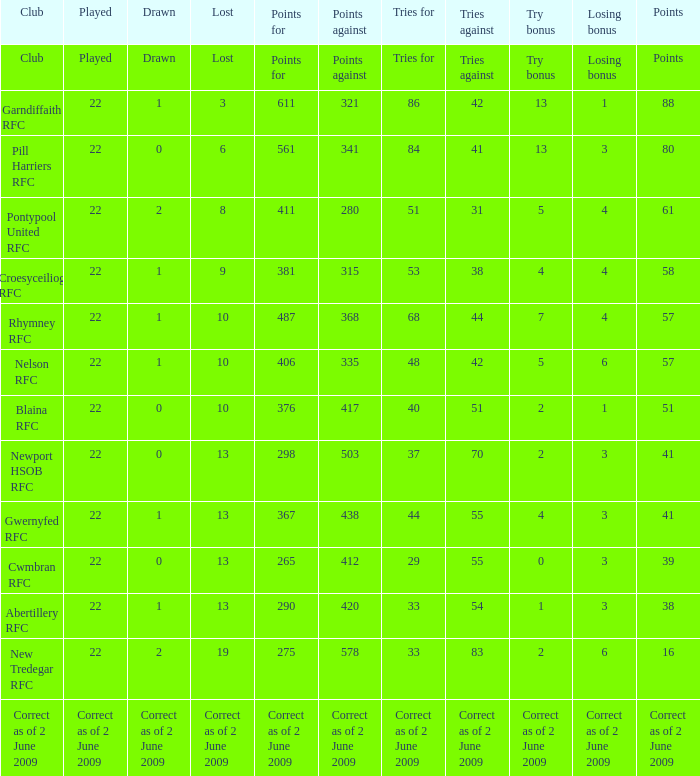Which club has 40 tries for? Blaina RFC. Could you parse the entire table as a dict? {'header': ['Club', 'Played', 'Drawn', 'Lost', 'Points for', 'Points against', 'Tries for', 'Tries against', 'Try bonus', 'Losing bonus', 'Points'], 'rows': [['Club', 'Played', 'Drawn', 'Lost', 'Points for', 'Points against', 'Tries for', 'Tries against', 'Try bonus', 'Losing bonus', 'Points'], ['Garndiffaith RFC', '22', '1', '3', '611', '321', '86', '42', '13', '1', '88'], ['Pill Harriers RFC', '22', '0', '6', '561', '341', '84', '41', '13', '3', '80'], ['Pontypool United RFC', '22', '2', '8', '411', '280', '51', '31', '5', '4', '61'], ['Croesyceiliog RFC', '22', '1', '9', '381', '315', '53', '38', '4', '4', '58'], ['Rhymney RFC', '22', '1', '10', '487', '368', '68', '44', '7', '4', '57'], ['Nelson RFC', '22', '1', '10', '406', '335', '48', '42', '5', '6', '57'], ['Blaina RFC', '22', '0', '10', '376', '417', '40', '51', '2', '1', '51'], ['Newport HSOB RFC', '22', '0', '13', '298', '503', '37', '70', '2', '3', '41'], ['Gwernyfed RFC', '22', '1', '13', '367', '438', '44', '55', '4', '3', '41'], ['Cwmbran RFC', '22', '0', '13', '265', '412', '29', '55', '0', '3', '39'], ['Abertillery RFC', '22', '1', '13', '290', '420', '33', '54', '1', '3', '38'], ['New Tredegar RFC', '22', '2', '19', '275', '578', '33', '83', '2', '6', '16'], ['Correct as of 2 June 2009', 'Correct as of 2 June 2009', 'Correct as of 2 June 2009', 'Correct as of 2 June 2009', 'Correct as of 2 June 2009', 'Correct as of 2 June 2009', 'Correct as of 2 June 2009', 'Correct as of 2 June 2009', 'Correct as of 2 June 2009', 'Correct as of 2 June 2009', 'Correct as of 2 June 2009']]} 